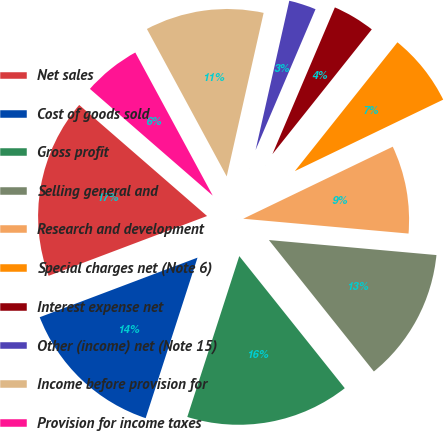Convert chart. <chart><loc_0><loc_0><loc_500><loc_500><pie_chart><fcel>Net sales<fcel>Cost of goods sold<fcel>Gross profit<fcel>Selling general and<fcel>Research and development<fcel>Special charges net (Note 6)<fcel>Interest expense net<fcel>Other (income) net (Note 15)<fcel>Income before provision for<fcel>Provision for income taxes<nl><fcel>17.13%<fcel>14.28%<fcel>15.7%<fcel>12.85%<fcel>8.57%<fcel>7.15%<fcel>4.3%<fcel>2.87%<fcel>11.43%<fcel>5.72%<nl></chart> 